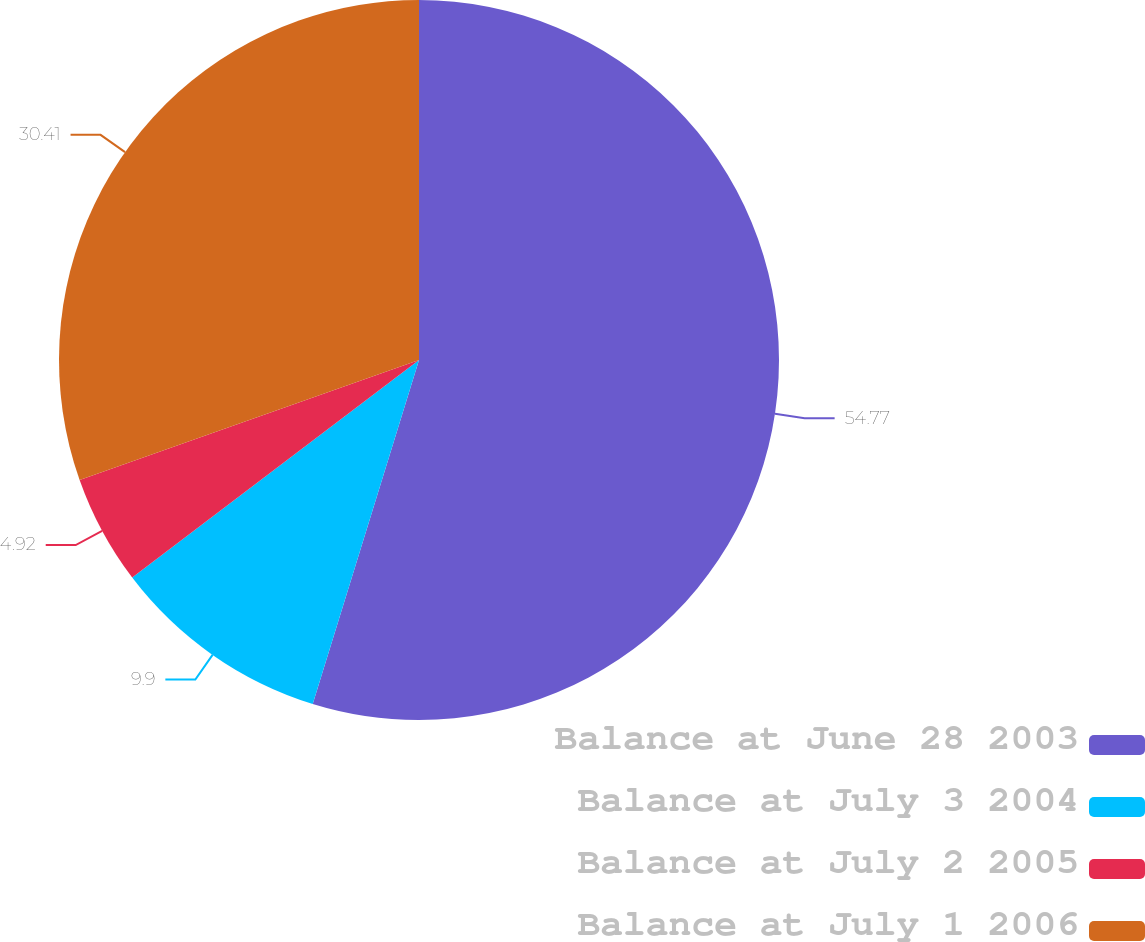<chart> <loc_0><loc_0><loc_500><loc_500><pie_chart><fcel>Balance at June 28 2003<fcel>Balance at July 3 2004<fcel>Balance at July 2 2005<fcel>Balance at July 1 2006<nl><fcel>54.77%<fcel>9.9%<fcel>4.92%<fcel>30.41%<nl></chart> 